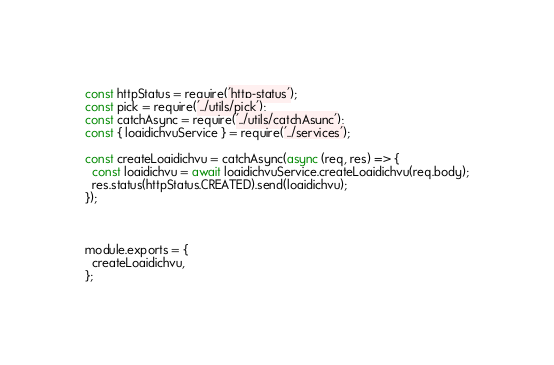Convert code to text. <code><loc_0><loc_0><loc_500><loc_500><_JavaScript_>const httpStatus = require('http-status');
const pick = require('../utils/pick');
const catchAsync = require('../utils/catchAsync');
const { loaidichvuService } = require('../services');

const createLoaidichvu = catchAsync(async (req, res) => {
  const loaidichvu = await loaidichvuService.createLoaidichvu(req.body);
  res.status(httpStatus.CREATED).send(loaidichvu);
});



module.exports = {
  createLoaidichvu,
};
</code> 